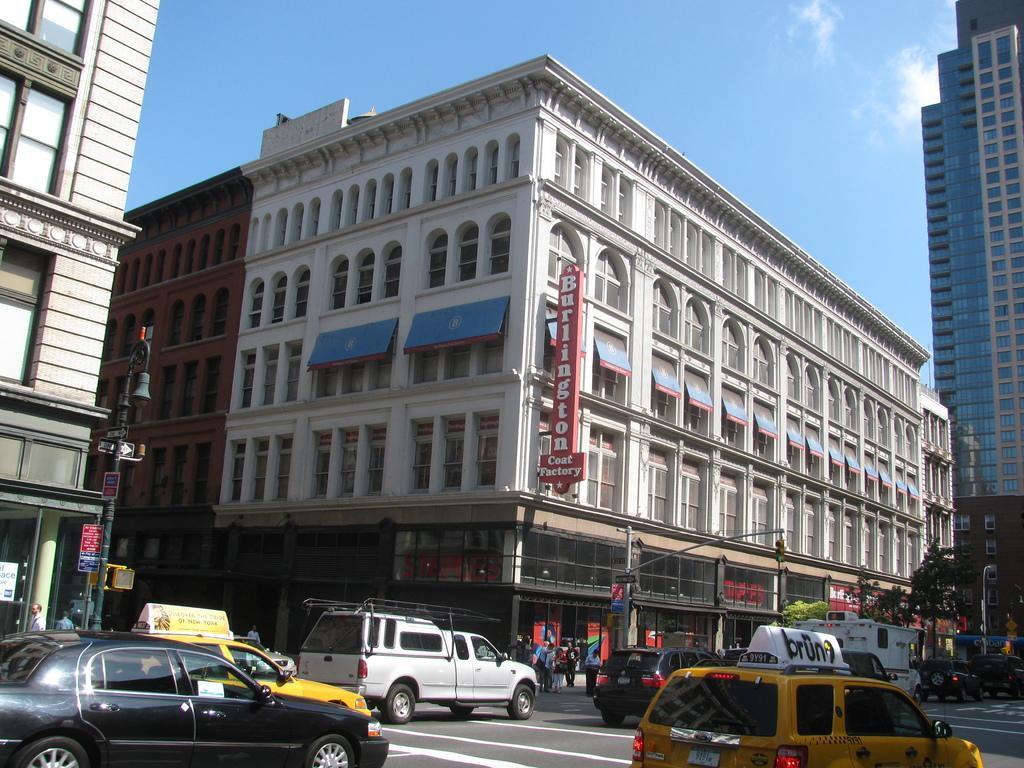<image>
Render a clear and concise summary of the photo. A Burlington Coat Factory is located at the corner of a busy intersection. 